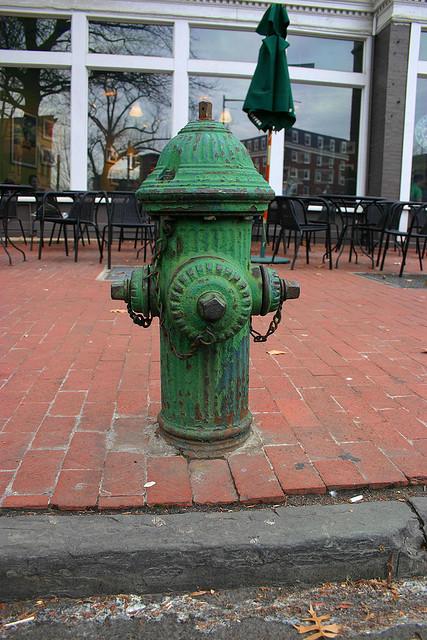What color is the fire hydrant?
Short answer required. Green. Is the umbrella open or closed?
Give a very brief answer. Closed. What is the walkway made of?
Keep it brief. Brick. How many objects can be easily moved?
Write a very short answer. 10. 